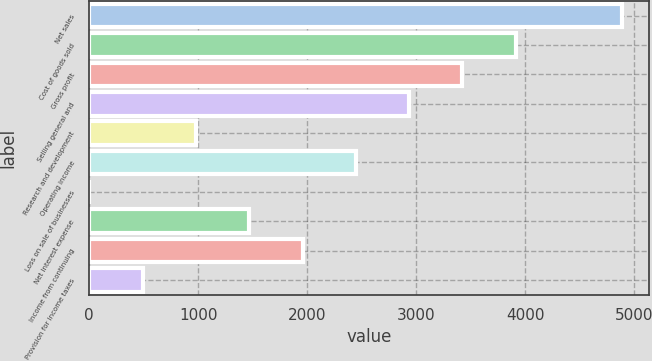Convert chart. <chart><loc_0><loc_0><loc_500><loc_500><bar_chart><fcel>Net sales<fcel>Cost of goods sold<fcel>Gross profit<fcel>Selling general and<fcel>Research and development<fcel>Operating income<fcel>Loss on sale of businesses<fcel>Net interest expense<fcel>Income from continuing<fcel>Provision for income taxes<nl><fcel>4890<fcel>3912.78<fcel>3424.17<fcel>2935.56<fcel>981.12<fcel>2446.95<fcel>3.9<fcel>1469.73<fcel>1958.34<fcel>492.51<nl></chart> 